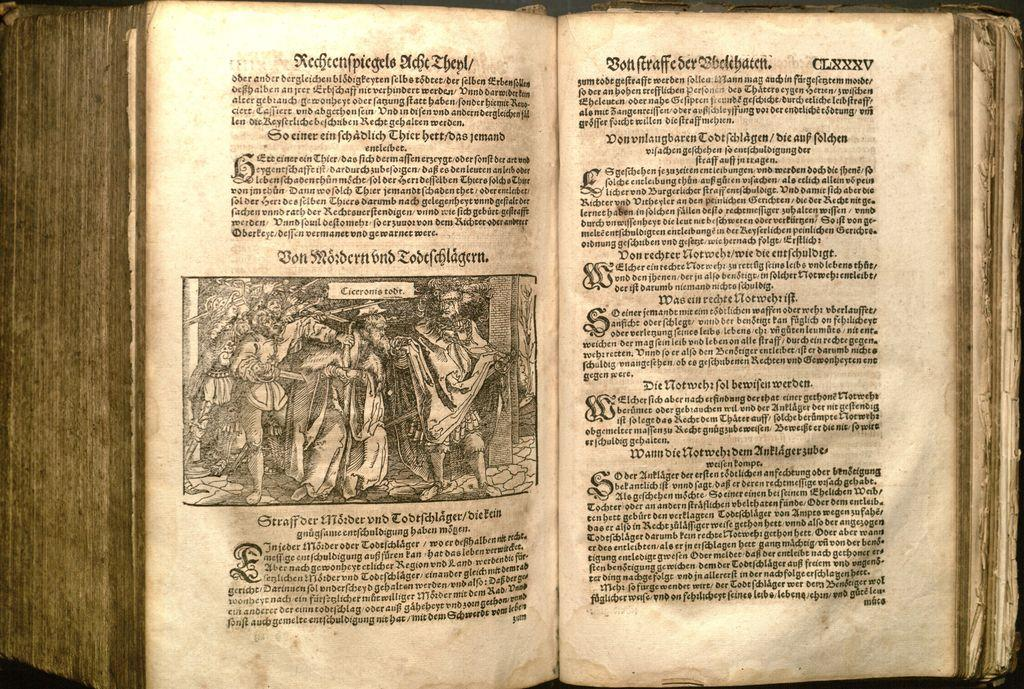<image>
Write a terse but informative summary of the picture. An ancient-looking book is opened to section CLXXXV. 